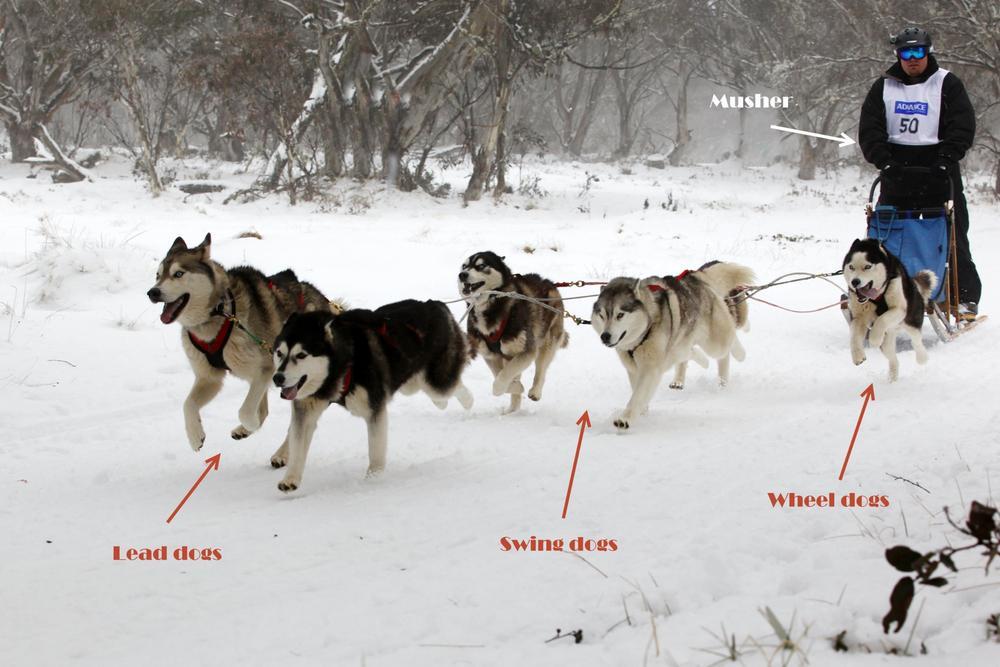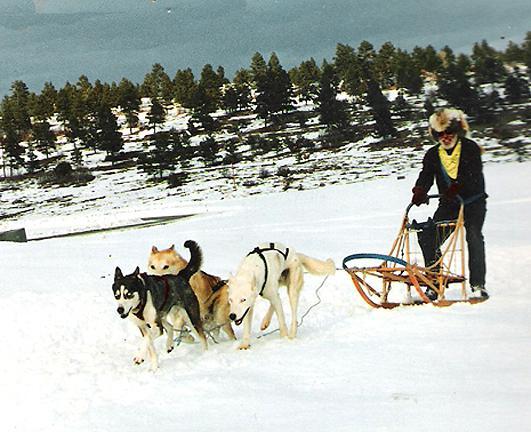The first image is the image on the left, the second image is the image on the right. Considering the images on both sides, is "There are at least three people in the sled in one of the images." valid? Answer yes or no. No. 